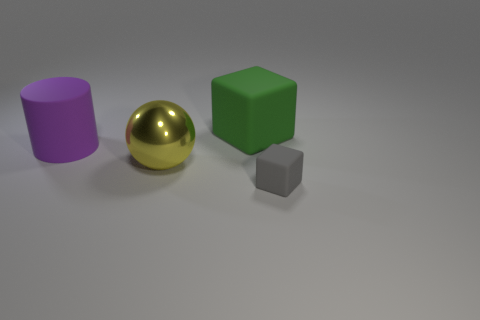Add 1 big brown metal cubes. How many objects exist? 5 Subtract all balls. How many objects are left? 3 Subtract all large red metallic blocks. Subtract all tiny rubber things. How many objects are left? 3 Add 3 metal things. How many metal things are left? 4 Add 3 gray matte blocks. How many gray matte blocks exist? 4 Subtract 0 green balls. How many objects are left? 4 